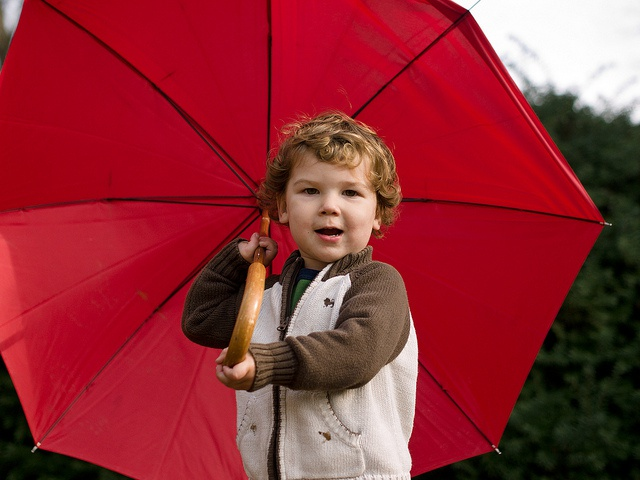Describe the objects in this image and their specific colors. I can see umbrella in brown, gray, maroon, and black tones and people in gray, black, darkgray, and maroon tones in this image. 